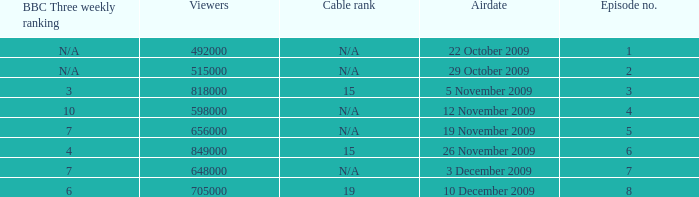What is the cable rank for the airdate of 10 december 2009? 19.0. 